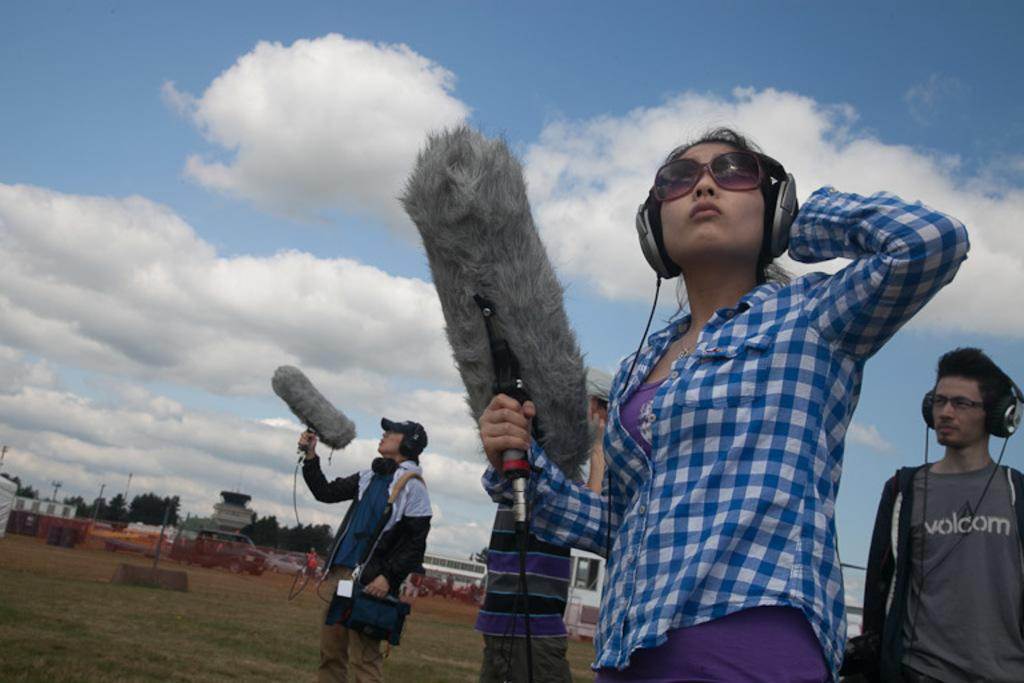How many people are in the image? There are persons in the image, but the exact number is not specified. What types of vehicles are on the ground in the image? The facts do not specify the types of vehicles on the ground. What can be seen in the background of the image? There are trees and the sky visible in the background of the image. What type of zephyr can be seen blowing through the trees in the image? There is no mention of a zephyr or any wind in the image, and therefore no such phenomenon can be observed. 